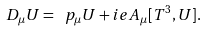<formula> <loc_0><loc_0><loc_500><loc_500>D _ { \mu } U = \ p _ { \mu } U + i e A _ { \mu } [ T ^ { 3 } , U ] .</formula> 